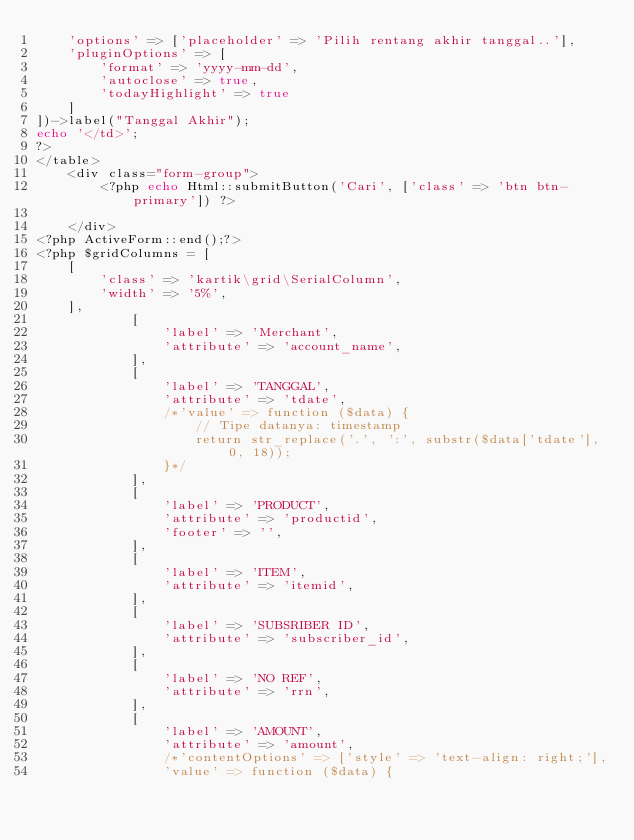<code> <loc_0><loc_0><loc_500><loc_500><_PHP_>    'options' => ['placeholder' => 'Pilih rentang akhir tanggal..'],
    'pluginOptions' => [
        'format' => 'yyyy-mm-dd',
        'autoclose' => true,
        'todayHighlight' => true
    ]
])->label("Tanggal Akhir");
echo '</td>';
?>
</table>
    <div class="form-group">
        <?php echo Html::submitButton('Cari', ['class' => 'btn btn-primary']) ?>

    </div>        
<?php ActiveForm::end();?>
<?php $gridColumns = [
    [
        'class' => 'kartik\grid\SerialColumn',
        'width' => '5%',
    ],
            [
                'label' => 'Merchant',
                'attribute' => 'account_name',
            ],
            [
                'label' => 'TANGGAL',
                'attribute' => 'tdate',
                /*'value' => function ($data) {
                    // Tipe datanya: timestamp
                    return str_replace('.', ':', substr($data['tdate'], 0, 18));
                }*/
            ],
            [
                'label' => 'PRODUCT',
                'attribute' => 'productid',
                'footer' => '',
            ],
            [
                'label' => 'ITEM',
                'attribute' => 'itemid',
            ],
            [
                'label' => 'SUBSRIBER ID',
                'attribute' => 'subscriber_id',
            ],
            [
                'label' => 'NO REF',
                'attribute' => 'rrn',
            ],
            [
                'label' => 'AMOUNT',
                'attribute' => 'amount',
                /*'contentOptions' => ['style' => 'text-align: right;'],
                'value' => function ($data) {</code> 